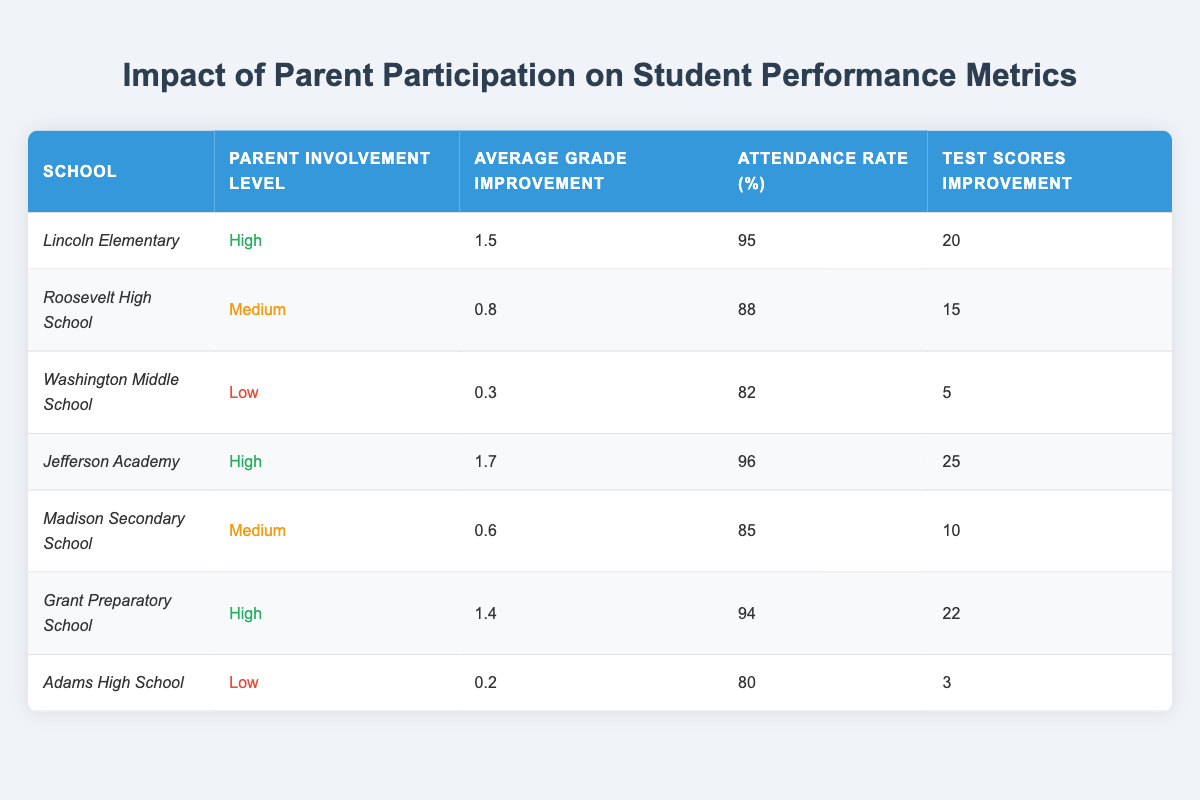What is the average grade improvement for Lincoln Elementary? According to the table, Lincoln Elementary has an average grade improvement of 1.5.
Answer: 1.5 Which school has the highest attendance rate? Reviewing the table, both Jefferson Academy and Lincoln Elementary have the highest attendance rate of 96%.
Answer: Jefferson Academy and Lincoln Elementary What is the test scores improvement for Washington Middle School? The table shows that Washington Middle School has a test scores improvement of 5.
Answer: 5 Which schools have high parent involvement levels? The table indicates that Lincoln Elementary, Jefferson Academy, and Grant Preparatory School have high parent involvement levels.
Answer: Lincoln Elementary, Jefferson Academy, Grant Preparatory School What is the difference in average grade improvement between high and low parent involvement schools? High involvement schools have average grade improvements of 1.5, 1.7, and 1.4, averaging at 1.53. Low involvement schools have 0.3 and 0.2, averaging at 0.25. The difference is 1.53 - 0.25 = 1.28.
Answer: 1.28 Does Adams High School have a higher attendance rate than Roosevelt High School? The attendance rate for Adams High School is 80%, and for Roosevelt High School, it is 88%. Since 80% is less than 88%, Adams does not have a higher rate.
Answer: No What is the average test scores improvement for schools with medium parent involvement? The test scores improvement for schools with medium involvement (Roosevelt High School and Madison Secondary School) is 15 and 10, respectively. Adding these gives 15 + 10 = 25, and dividing by 2 yields an average of 25 / 2 = 12.5.
Answer: 12.5 Which school showed the lowest improvement in average grades? The table indicates that Adams High School showed the lowest average grade improvement at 0.2.
Answer: 0.2 What is the attendance rate for schools with low parent involvement? For low involvement schools, Washington Middle School has an attendance rate of 82%, and Adams High School has 80%. Their average attendance rate is (82 + 80) / 2 = 81%.
Answer: 81% Which school has the largest improvement in test scores? Jefferson Academy has the largest test scores improvement at 25, as indicated in the table.
Answer: 25 